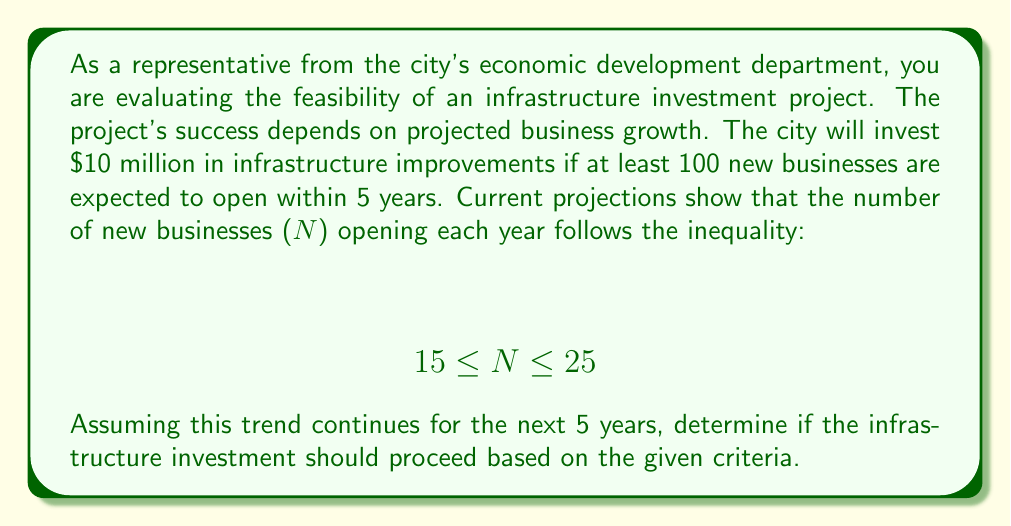What is the answer to this math problem? To solve this problem, we need to evaluate the minimum and maximum number of new businesses that could open over the 5-year period:

1. Minimum number of new businesses:
   $$ 5 \times 15 = 75 $$

2. Maximum number of new businesses:
   $$ 5 \times 25 = 125 $$

Therefore, the total number of new businesses (T) over 5 years satisfies the inequality:

$$ 75 \leq T \leq 125 $$

The city's criterion for investment is that at least 100 new businesses should open within 5 years. We can see that:

1. The minimum possible number (75) is less than 100.
2. The maximum possible number (125) is greater than 100.

This means that the target of 100 new businesses falls within the range of possible outcomes. However, we cannot guarantee that this target will be met, as there is a possibility that fewer than 100 businesses might open.

Given the uncertainty, the city should consider additional factors before proceeding with the investment, such as:

1. The potential economic impact of the infrastructure improvements
2. The likelihood of achieving the upper end of the business growth projection
3. The risks associated with not meeting the 100-business target
4. Alternative investment opportunities with more certain outcomes
Answer: Based on the given criteria and projections, the feasibility of the infrastructure investment is uncertain. The target of 100 new businesses falls within the possible range (75 to 125), but it is not guaranteed. The city should carefully consider additional economic factors before making a decision on the $10 million investment. 